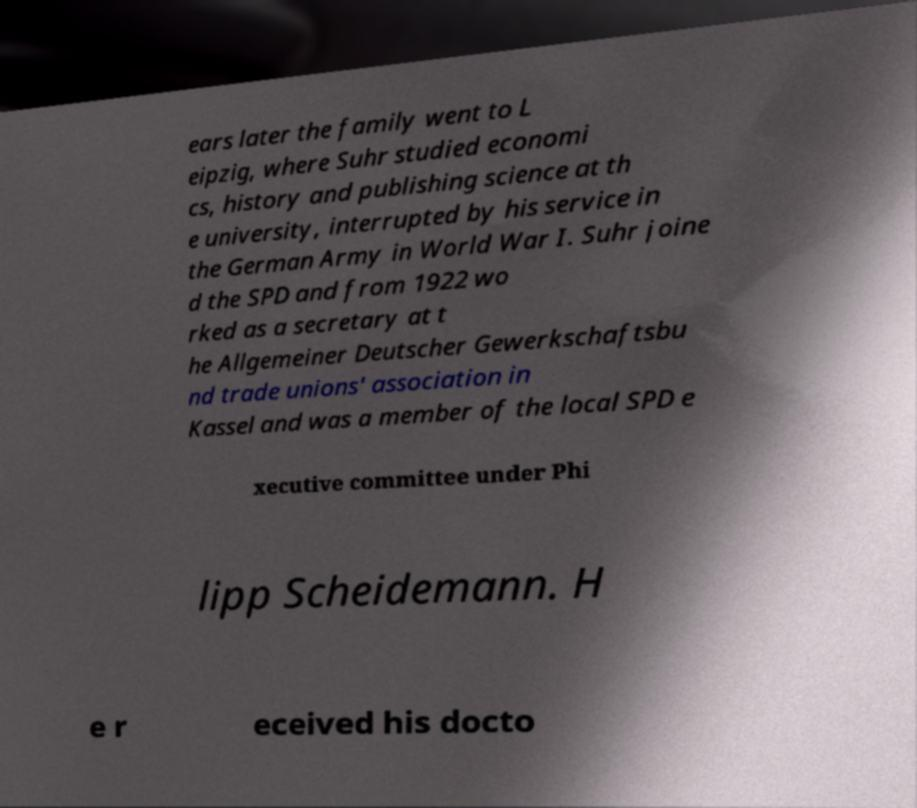There's text embedded in this image that I need extracted. Can you transcribe it verbatim? ears later the family went to L eipzig, where Suhr studied economi cs, history and publishing science at th e university, interrupted by his service in the German Army in World War I. Suhr joine d the SPD and from 1922 wo rked as a secretary at t he Allgemeiner Deutscher Gewerkschaftsbu nd trade unions' association in Kassel and was a member of the local SPD e xecutive committee under Phi lipp Scheidemann. H e r eceived his docto 